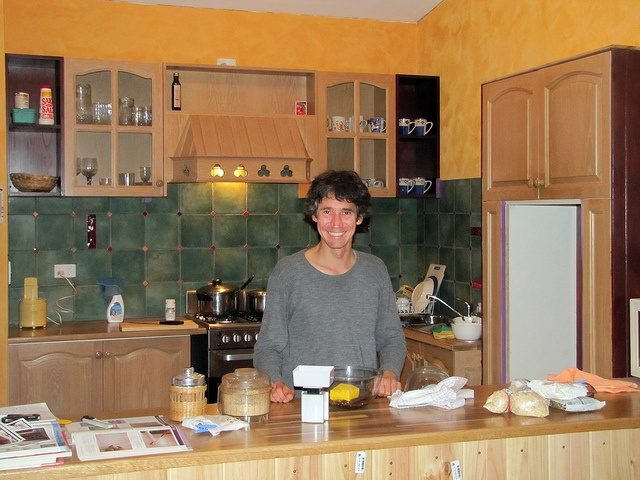Describe the objects in this image and their specific colors. I can see people in orange, gray, black, and salmon tones, book in orange, lightgray, tan, darkgray, and gray tones, oven in orange, black, gray, and maroon tones, book in orange, ivory, darkgray, pink, and gray tones, and cup in orange, gray, tan, and maroon tones in this image. 